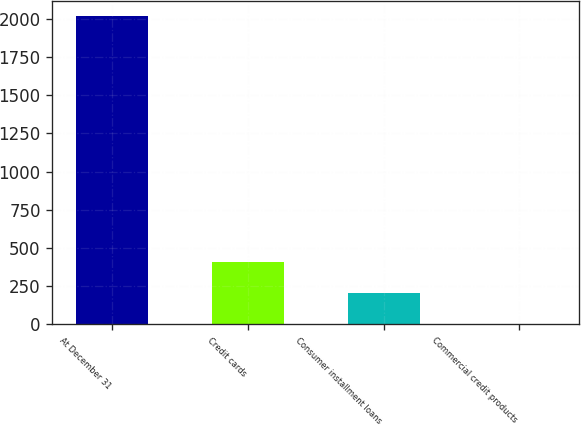<chart> <loc_0><loc_0><loc_500><loc_500><bar_chart><fcel>At December 31<fcel>Credit cards<fcel>Consumer installment loans<fcel>Commercial credit products<nl><fcel>2018<fcel>407.6<fcel>206.3<fcel>5<nl></chart> 